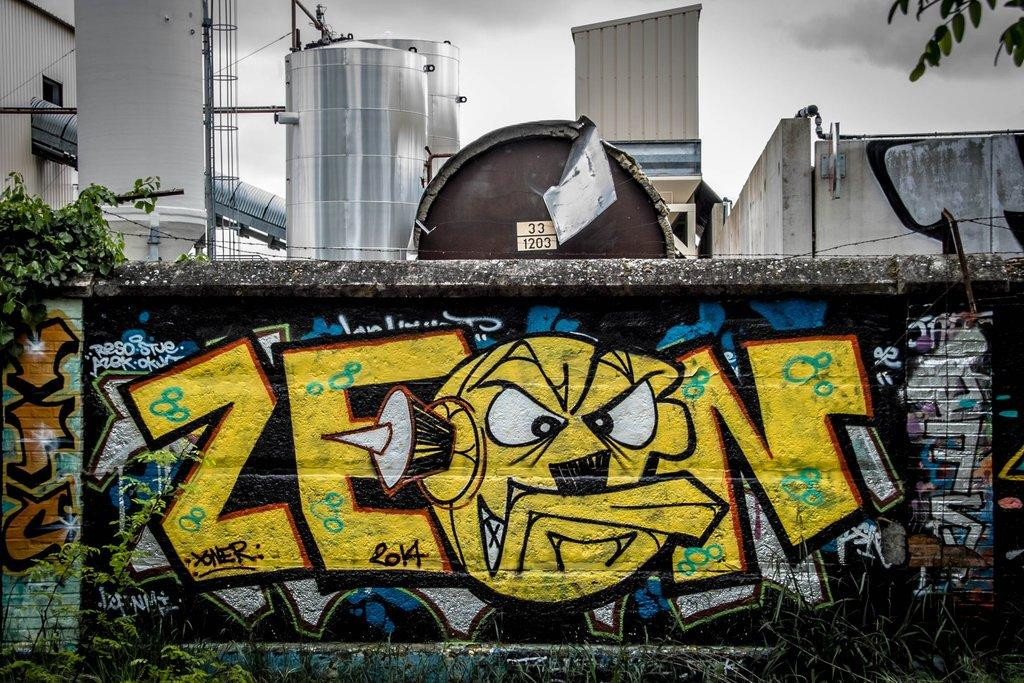What can be seen on the wall in the image? There are paintings and a plant on the wall. What is visible in the background of the image? There are tanks, a pillar, a tower, a wall, and a building in the background. What is the condition of the sky in the image? There are clouds in the sky in the image. What is the process of measuring the distance between the tower and the building in the image? There is no need to measure the distance between the tower and the building in the image, as the question is not relevant to the information provided. 